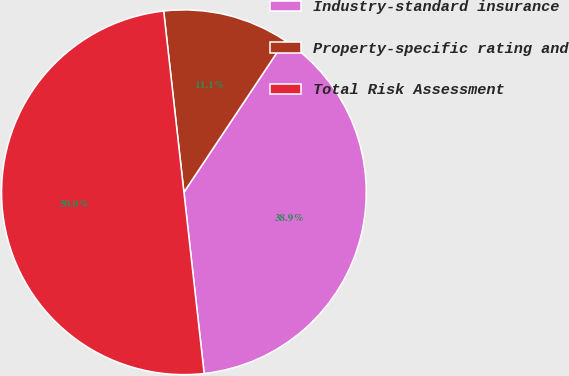Convert chart. <chart><loc_0><loc_0><loc_500><loc_500><pie_chart><fcel>Industry-standard insurance<fcel>Property-specific rating and<fcel>Total Risk Assessment<nl><fcel>38.88%<fcel>11.12%<fcel>50.0%<nl></chart> 